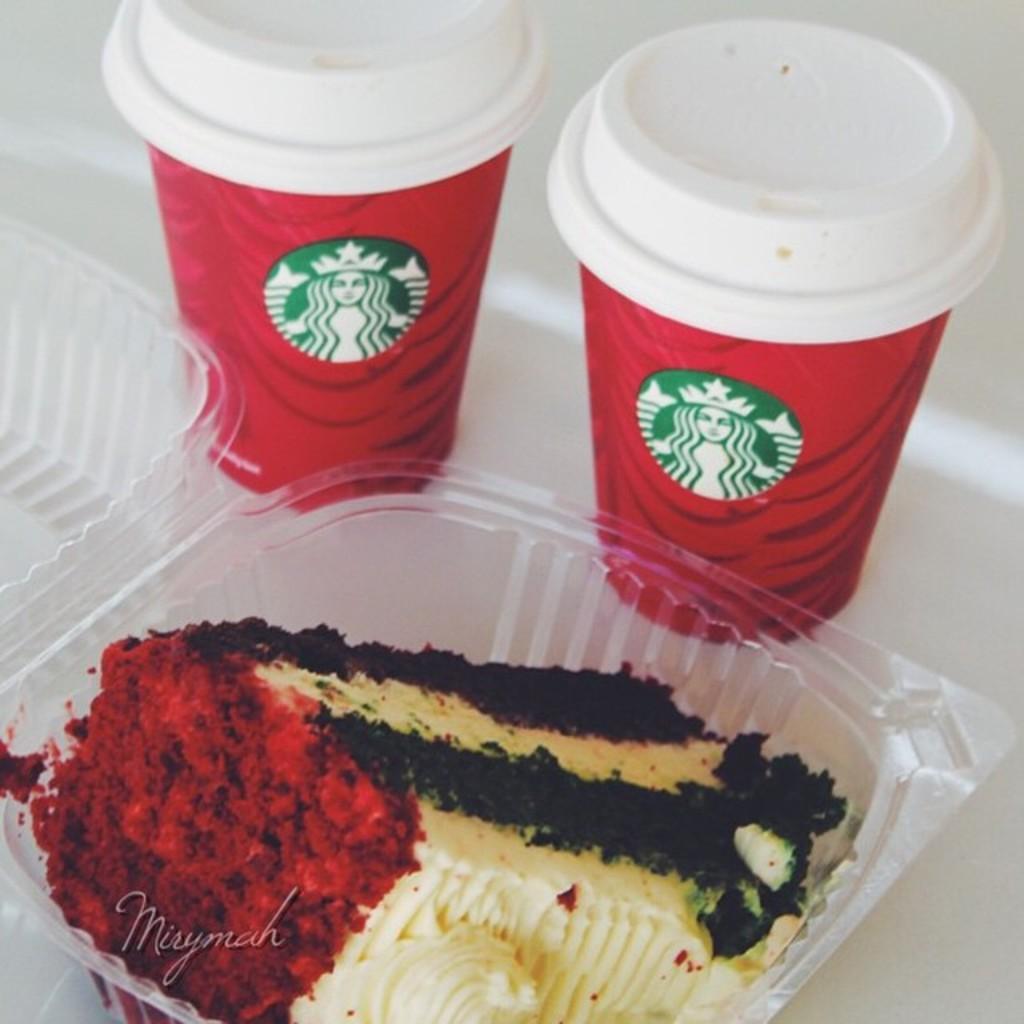In one or two sentences, can you explain what this image depicts? In this image I see the plastic box on which there is food which is of cream, black and red in color and I see 2 cups over here which are of white and red in color and I see logos on it and these 3 things are on the white surface. 